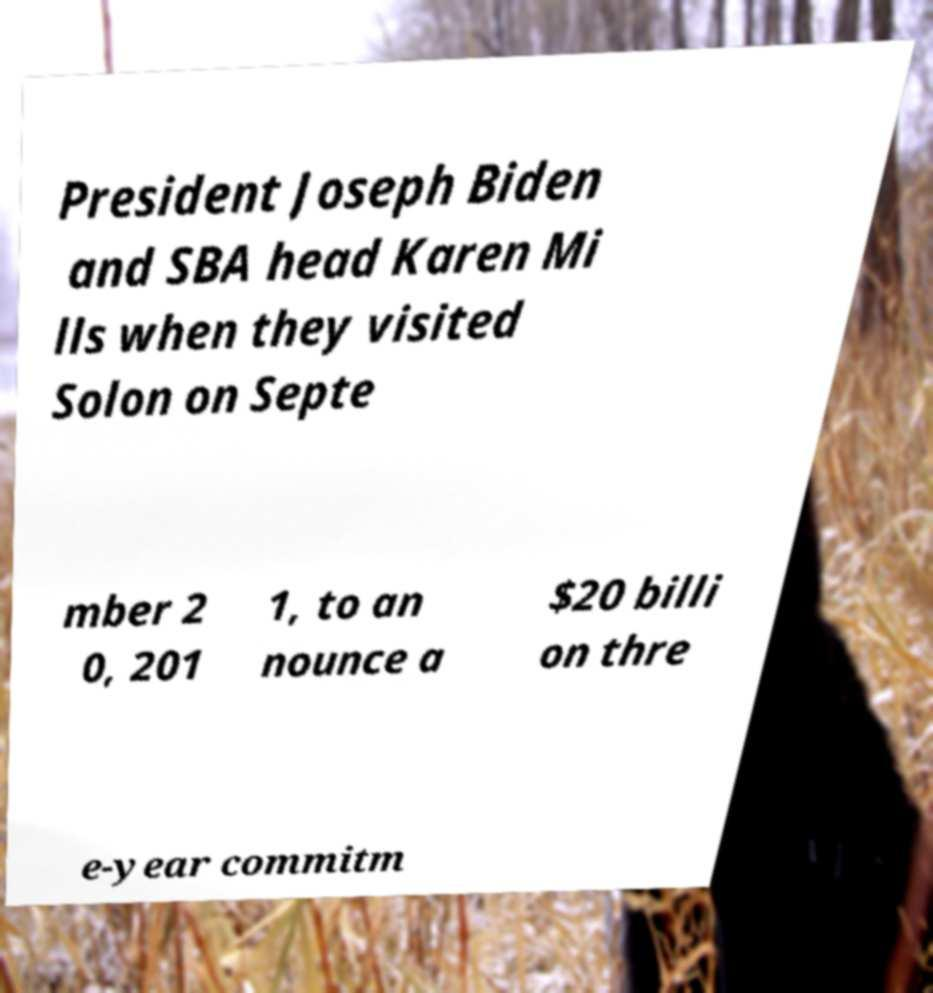I need the written content from this picture converted into text. Can you do that? President Joseph Biden and SBA head Karen Mi lls when they visited Solon on Septe mber 2 0, 201 1, to an nounce a $20 billi on thre e-year commitm 